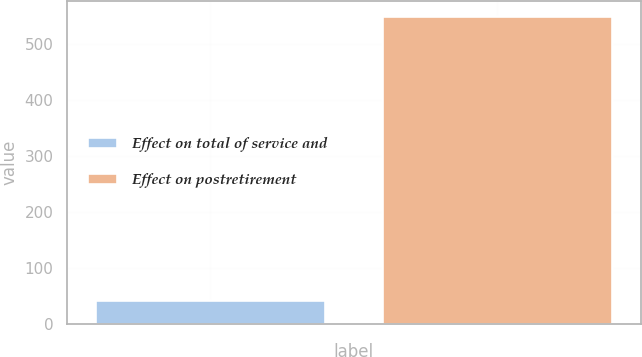Convert chart. <chart><loc_0><loc_0><loc_500><loc_500><bar_chart><fcel>Effect on total of service and<fcel>Effect on postretirement<nl><fcel>44<fcel>551<nl></chart> 